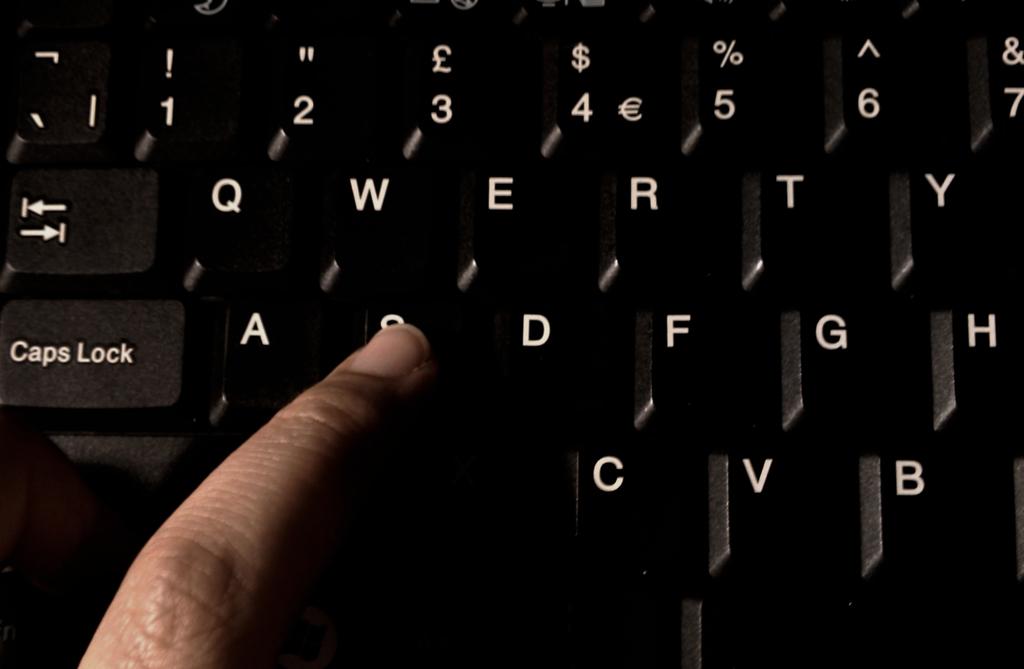What can you spell with the letters on this keyboard?
Give a very brief answer. Qwerty. What type is the lock key?
Offer a terse response. Caps. 